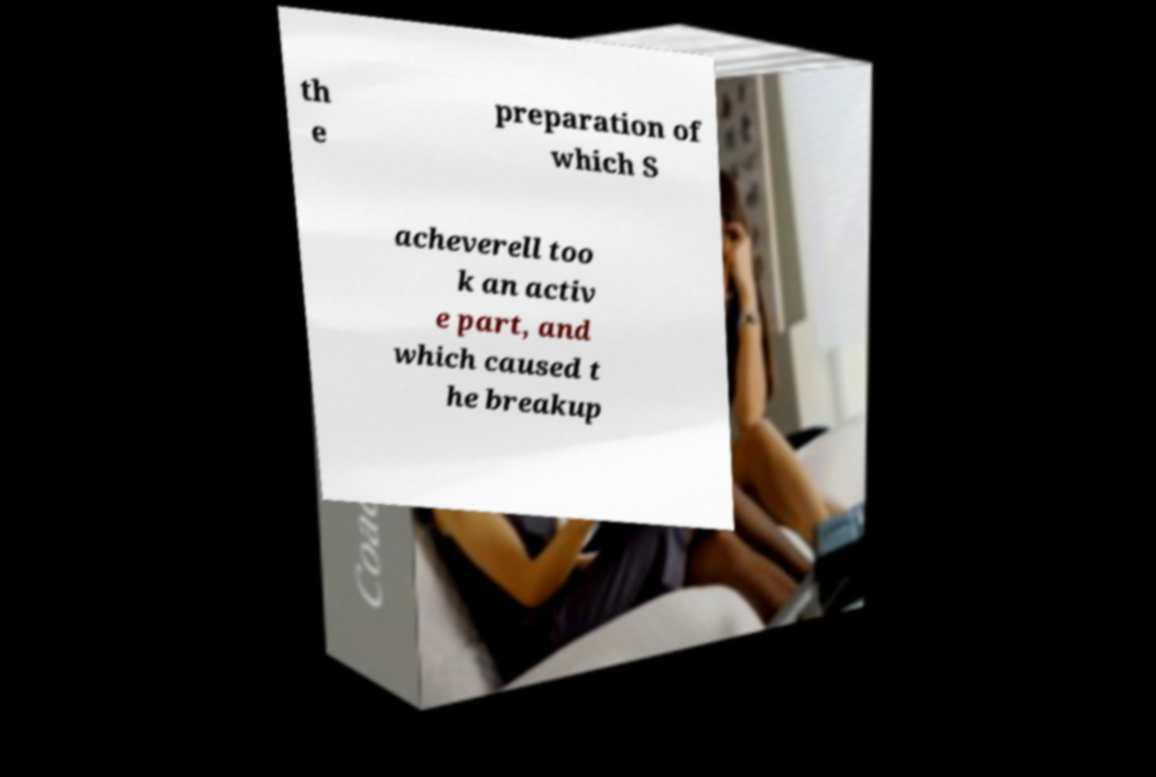Can you accurately transcribe the text from the provided image for me? th e preparation of which S acheverell too k an activ e part, and which caused t he breakup 